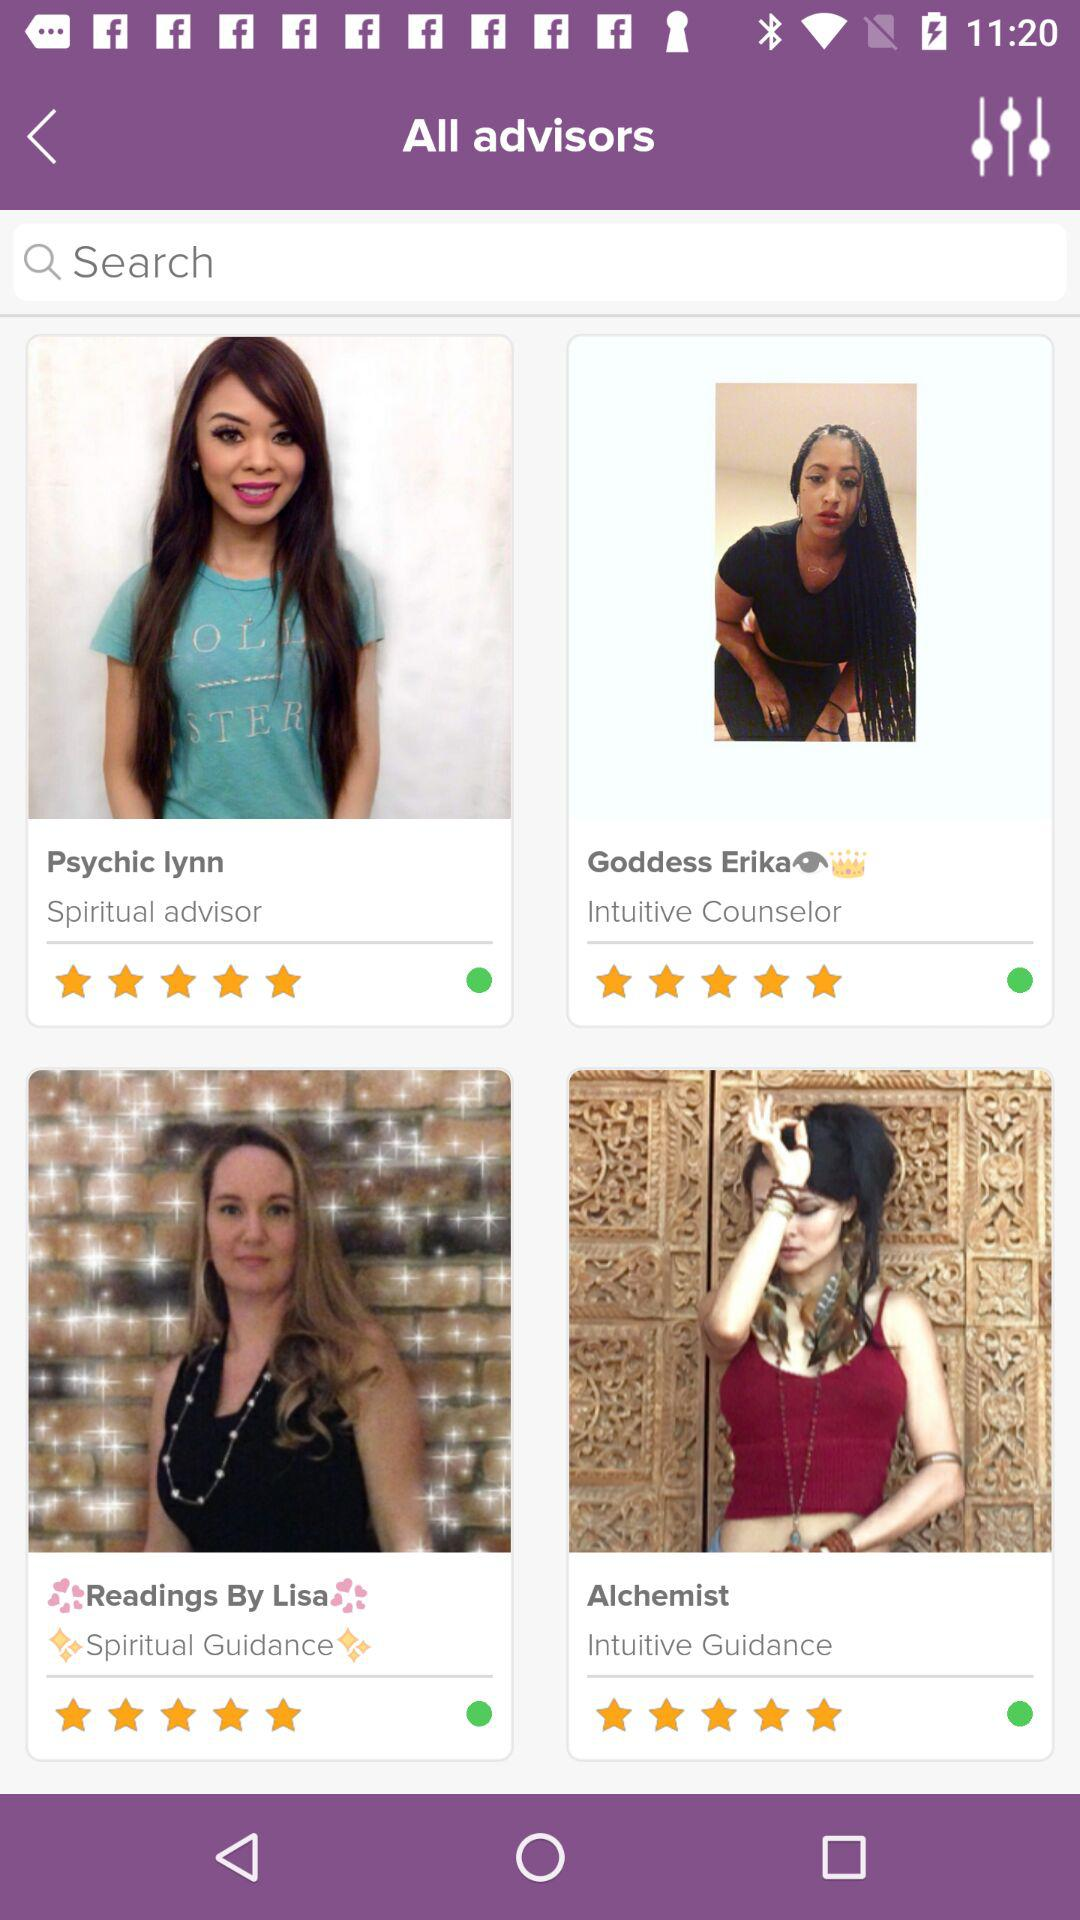What is the star rating of Psychic Lynn? The star rating of Psychic Lynn is 5. 